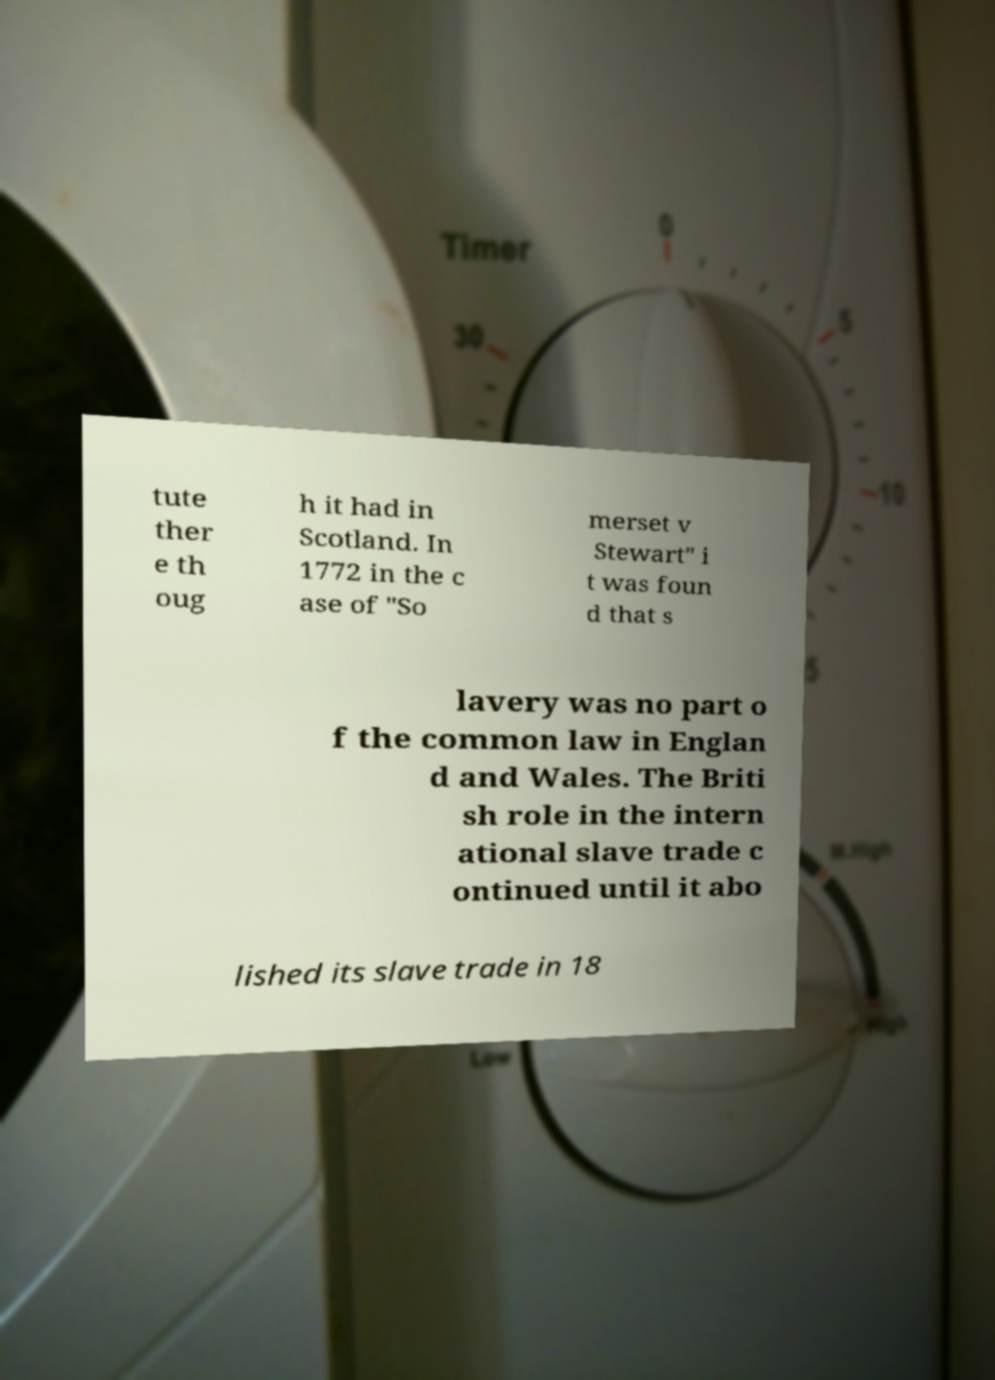Could you assist in decoding the text presented in this image and type it out clearly? tute ther e th oug h it had in Scotland. In 1772 in the c ase of "So merset v Stewart" i t was foun d that s lavery was no part o f the common law in Englan d and Wales. The Briti sh role in the intern ational slave trade c ontinued until it abo lished its slave trade in 18 